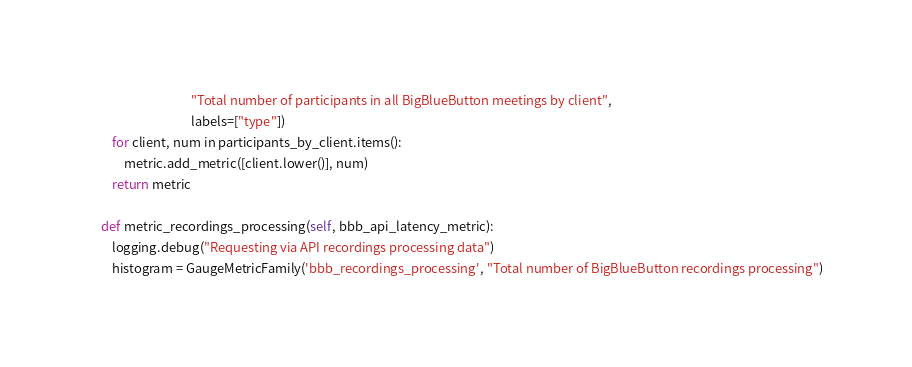<code> <loc_0><loc_0><loc_500><loc_500><_Python_>                                   "Total number of participants in all BigBlueButton meetings by client",
                                   labels=["type"])
        for client, num in participants_by_client.items():
            metric.add_metric([client.lower()], num)
        return metric

    def metric_recordings_processing(self, bbb_api_latency_metric):
        logging.debug("Requesting via API recordings processing data")
        histogram = GaugeMetricFamily('bbb_recordings_processing', "Total number of BigBlueButton recordings processing")</code> 